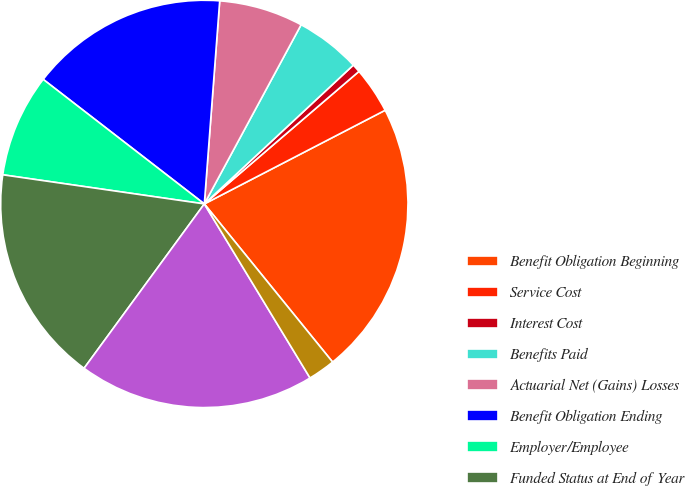<chart> <loc_0><loc_0><loc_500><loc_500><pie_chart><fcel>Benefit Obligation Beginning<fcel>Service Cost<fcel>Interest Cost<fcel>Benefits Paid<fcel>Actuarial Net (Gains) Losses<fcel>Benefit Obligation Ending<fcel>Employer/Employee<fcel>Funded Status at End of Year<fcel>Net Amount Recognized in<fcel>Current Liabilities<nl><fcel>21.76%<fcel>3.67%<fcel>0.66%<fcel>5.18%<fcel>6.68%<fcel>15.73%<fcel>8.19%<fcel>17.23%<fcel>18.74%<fcel>2.16%<nl></chart> 